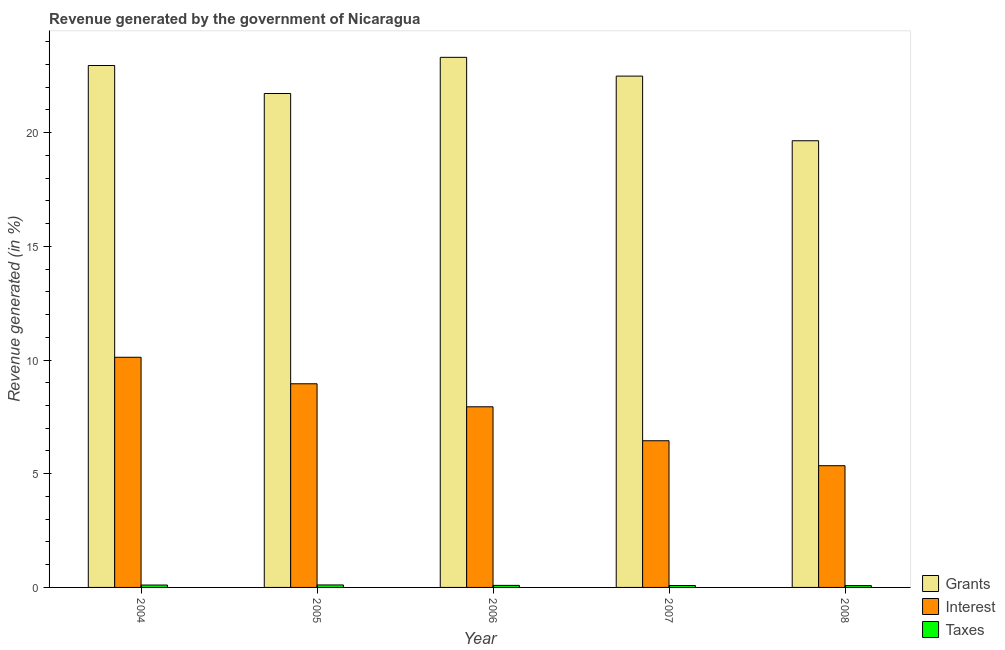How many groups of bars are there?
Your response must be concise. 5. Are the number of bars per tick equal to the number of legend labels?
Make the answer very short. Yes. Are the number of bars on each tick of the X-axis equal?
Offer a terse response. Yes. How many bars are there on the 4th tick from the left?
Make the answer very short. 3. What is the percentage of revenue generated by grants in 2004?
Offer a terse response. 22.95. Across all years, what is the maximum percentage of revenue generated by grants?
Ensure brevity in your answer.  23.31. Across all years, what is the minimum percentage of revenue generated by interest?
Offer a very short reply. 5.35. In which year was the percentage of revenue generated by grants maximum?
Your answer should be compact. 2006. What is the total percentage of revenue generated by interest in the graph?
Ensure brevity in your answer.  38.82. What is the difference between the percentage of revenue generated by grants in 2006 and that in 2007?
Your answer should be very brief. 0.83. What is the difference between the percentage of revenue generated by taxes in 2006 and the percentage of revenue generated by grants in 2008?
Offer a very short reply. 0.01. What is the average percentage of revenue generated by interest per year?
Provide a short and direct response. 7.76. In how many years, is the percentage of revenue generated by interest greater than 18 %?
Your response must be concise. 0. What is the ratio of the percentage of revenue generated by interest in 2006 to that in 2008?
Keep it short and to the point. 1.48. Is the percentage of revenue generated by taxes in 2006 less than that in 2008?
Provide a short and direct response. No. What is the difference between the highest and the second highest percentage of revenue generated by grants?
Offer a terse response. 0.36. What is the difference between the highest and the lowest percentage of revenue generated by interest?
Give a very brief answer. 4.77. What does the 3rd bar from the left in 2004 represents?
Provide a short and direct response. Taxes. What does the 1st bar from the right in 2005 represents?
Provide a succinct answer. Taxes. Is it the case that in every year, the sum of the percentage of revenue generated by grants and percentage of revenue generated by interest is greater than the percentage of revenue generated by taxes?
Give a very brief answer. Yes. How many bars are there?
Your response must be concise. 15. Are all the bars in the graph horizontal?
Your response must be concise. No. What is the difference between two consecutive major ticks on the Y-axis?
Your answer should be very brief. 5. Does the graph contain any zero values?
Offer a very short reply. No. Where does the legend appear in the graph?
Your response must be concise. Bottom right. What is the title of the graph?
Give a very brief answer. Revenue generated by the government of Nicaragua. Does "Unemployment benefits" appear as one of the legend labels in the graph?
Provide a short and direct response. No. What is the label or title of the X-axis?
Offer a terse response. Year. What is the label or title of the Y-axis?
Provide a succinct answer. Revenue generated (in %). What is the Revenue generated (in %) in Grants in 2004?
Your answer should be very brief. 22.95. What is the Revenue generated (in %) in Interest in 2004?
Give a very brief answer. 10.12. What is the Revenue generated (in %) of Taxes in 2004?
Your answer should be compact. 0.1. What is the Revenue generated (in %) of Grants in 2005?
Your answer should be very brief. 21.72. What is the Revenue generated (in %) of Interest in 2005?
Offer a terse response. 8.96. What is the Revenue generated (in %) in Taxes in 2005?
Keep it short and to the point. 0.11. What is the Revenue generated (in %) of Grants in 2006?
Provide a succinct answer. 23.31. What is the Revenue generated (in %) in Interest in 2006?
Give a very brief answer. 7.94. What is the Revenue generated (in %) in Taxes in 2006?
Ensure brevity in your answer.  0.09. What is the Revenue generated (in %) in Grants in 2007?
Your answer should be very brief. 22.48. What is the Revenue generated (in %) of Interest in 2007?
Provide a short and direct response. 6.45. What is the Revenue generated (in %) of Taxes in 2007?
Make the answer very short. 0.08. What is the Revenue generated (in %) in Grants in 2008?
Offer a terse response. 19.64. What is the Revenue generated (in %) in Interest in 2008?
Your answer should be very brief. 5.35. What is the Revenue generated (in %) of Taxes in 2008?
Offer a terse response. 0.08. Across all years, what is the maximum Revenue generated (in %) in Grants?
Your answer should be very brief. 23.31. Across all years, what is the maximum Revenue generated (in %) in Interest?
Your answer should be very brief. 10.12. Across all years, what is the maximum Revenue generated (in %) in Taxes?
Ensure brevity in your answer.  0.11. Across all years, what is the minimum Revenue generated (in %) of Grants?
Provide a succinct answer. 19.64. Across all years, what is the minimum Revenue generated (in %) of Interest?
Offer a very short reply. 5.35. Across all years, what is the minimum Revenue generated (in %) in Taxes?
Offer a very short reply. 0.08. What is the total Revenue generated (in %) in Grants in the graph?
Provide a short and direct response. 110.11. What is the total Revenue generated (in %) of Interest in the graph?
Your answer should be very brief. 38.82. What is the total Revenue generated (in %) of Taxes in the graph?
Your response must be concise. 0.47. What is the difference between the Revenue generated (in %) of Grants in 2004 and that in 2005?
Keep it short and to the point. 1.23. What is the difference between the Revenue generated (in %) in Interest in 2004 and that in 2005?
Offer a terse response. 1.17. What is the difference between the Revenue generated (in %) of Taxes in 2004 and that in 2005?
Keep it short and to the point. -0. What is the difference between the Revenue generated (in %) of Grants in 2004 and that in 2006?
Give a very brief answer. -0.36. What is the difference between the Revenue generated (in %) in Interest in 2004 and that in 2006?
Your response must be concise. 2.18. What is the difference between the Revenue generated (in %) of Taxes in 2004 and that in 2006?
Ensure brevity in your answer.  0.02. What is the difference between the Revenue generated (in %) in Grants in 2004 and that in 2007?
Your response must be concise. 0.47. What is the difference between the Revenue generated (in %) in Interest in 2004 and that in 2007?
Give a very brief answer. 3.67. What is the difference between the Revenue generated (in %) of Taxes in 2004 and that in 2007?
Offer a terse response. 0.02. What is the difference between the Revenue generated (in %) in Grants in 2004 and that in 2008?
Provide a succinct answer. 3.31. What is the difference between the Revenue generated (in %) in Interest in 2004 and that in 2008?
Keep it short and to the point. 4.77. What is the difference between the Revenue generated (in %) in Taxes in 2004 and that in 2008?
Make the answer very short. 0.03. What is the difference between the Revenue generated (in %) of Grants in 2005 and that in 2006?
Provide a short and direct response. -1.59. What is the difference between the Revenue generated (in %) in Interest in 2005 and that in 2006?
Keep it short and to the point. 1.01. What is the difference between the Revenue generated (in %) in Taxes in 2005 and that in 2006?
Give a very brief answer. 0.02. What is the difference between the Revenue generated (in %) in Grants in 2005 and that in 2007?
Your answer should be very brief. -0.76. What is the difference between the Revenue generated (in %) of Interest in 2005 and that in 2007?
Provide a short and direct response. 2.5. What is the difference between the Revenue generated (in %) of Taxes in 2005 and that in 2007?
Keep it short and to the point. 0.02. What is the difference between the Revenue generated (in %) of Grants in 2005 and that in 2008?
Offer a terse response. 2.08. What is the difference between the Revenue generated (in %) of Interest in 2005 and that in 2008?
Make the answer very short. 3.6. What is the difference between the Revenue generated (in %) in Taxes in 2005 and that in 2008?
Your answer should be compact. 0.03. What is the difference between the Revenue generated (in %) in Grants in 2006 and that in 2007?
Provide a succinct answer. 0.83. What is the difference between the Revenue generated (in %) in Interest in 2006 and that in 2007?
Offer a terse response. 1.49. What is the difference between the Revenue generated (in %) in Taxes in 2006 and that in 2007?
Make the answer very short. 0.01. What is the difference between the Revenue generated (in %) of Grants in 2006 and that in 2008?
Ensure brevity in your answer.  3.67. What is the difference between the Revenue generated (in %) in Interest in 2006 and that in 2008?
Your answer should be compact. 2.59. What is the difference between the Revenue generated (in %) in Taxes in 2006 and that in 2008?
Make the answer very short. 0.01. What is the difference between the Revenue generated (in %) in Grants in 2007 and that in 2008?
Offer a very short reply. 2.84. What is the difference between the Revenue generated (in %) in Interest in 2007 and that in 2008?
Your answer should be compact. 1.1. What is the difference between the Revenue generated (in %) in Taxes in 2007 and that in 2008?
Offer a terse response. 0. What is the difference between the Revenue generated (in %) in Grants in 2004 and the Revenue generated (in %) in Interest in 2005?
Provide a short and direct response. 14. What is the difference between the Revenue generated (in %) in Grants in 2004 and the Revenue generated (in %) in Taxes in 2005?
Offer a terse response. 22.84. What is the difference between the Revenue generated (in %) of Interest in 2004 and the Revenue generated (in %) of Taxes in 2005?
Provide a short and direct response. 10.01. What is the difference between the Revenue generated (in %) of Grants in 2004 and the Revenue generated (in %) of Interest in 2006?
Offer a terse response. 15.01. What is the difference between the Revenue generated (in %) in Grants in 2004 and the Revenue generated (in %) in Taxes in 2006?
Your answer should be very brief. 22.86. What is the difference between the Revenue generated (in %) in Interest in 2004 and the Revenue generated (in %) in Taxes in 2006?
Your answer should be compact. 10.03. What is the difference between the Revenue generated (in %) in Grants in 2004 and the Revenue generated (in %) in Interest in 2007?
Offer a very short reply. 16.5. What is the difference between the Revenue generated (in %) in Grants in 2004 and the Revenue generated (in %) in Taxes in 2007?
Ensure brevity in your answer.  22.87. What is the difference between the Revenue generated (in %) of Interest in 2004 and the Revenue generated (in %) of Taxes in 2007?
Your answer should be very brief. 10.04. What is the difference between the Revenue generated (in %) of Grants in 2004 and the Revenue generated (in %) of Interest in 2008?
Offer a terse response. 17.6. What is the difference between the Revenue generated (in %) of Grants in 2004 and the Revenue generated (in %) of Taxes in 2008?
Offer a terse response. 22.87. What is the difference between the Revenue generated (in %) of Interest in 2004 and the Revenue generated (in %) of Taxes in 2008?
Give a very brief answer. 10.04. What is the difference between the Revenue generated (in %) of Grants in 2005 and the Revenue generated (in %) of Interest in 2006?
Offer a terse response. 13.78. What is the difference between the Revenue generated (in %) in Grants in 2005 and the Revenue generated (in %) in Taxes in 2006?
Your answer should be very brief. 21.63. What is the difference between the Revenue generated (in %) in Interest in 2005 and the Revenue generated (in %) in Taxes in 2006?
Make the answer very short. 8.87. What is the difference between the Revenue generated (in %) of Grants in 2005 and the Revenue generated (in %) of Interest in 2007?
Your response must be concise. 15.27. What is the difference between the Revenue generated (in %) in Grants in 2005 and the Revenue generated (in %) in Taxes in 2007?
Keep it short and to the point. 21.64. What is the difference between the Revenue generated (in %) of Interest in 2005 and the Revenue generated (in %) of Taxes in 2007?
Provide a succinct answer. 8.87. What is the difference between the Revenue generated (in %) of Grants in 2005 and the Revenue generated (in %) of Interest in 2008?
Offer a terse response. 16.37. What is the difference between the Revenue generated (in %) of Grants in 2005 and the Revenue generated (in %) of Taxes in 2008?
Keep it short and to the point. 21.64. What is the difference between the Revenue generated (in %) of Interest in 2005 and the Revenue generated (in %) of Taxes in 2008?
Your answer should be very brief. 8.88. What is the difference between the Revenue generated (in %) of Grants in 2006 and the Revenue generated (in %) of Interest in 2007?
Provide a succinct answer. 16.86. What is the difference between the Revenue generated (in %) of Grants in 2006 and the Revenue generated (in %) of Taxes in 2007?
Provide a short and direct response. 23.23. What is the difference between the Revenue generated (in %) of Interest in 2006 and the Revenue generated (in %) of Taxes in 2007?
Ensure brevity in your answer.  7.86. What is the difference between the Revenue generated (in %) in Grants in 2006 and the Revenue generated (in %) in Interest in 2008?
Offer a terse response. 17.96. What is the difference between the Revenue generated (in %) in Grants in 2006 and the Revenue generated (in %) in Taxes in 2008?
Your answer should be very brief. 23.23. What is the difference between the Revenue generated (in %) in Interest in 2006 and the Revenue generated (in %) in Taxes in 2008?
Provide a short and direct response. 7.86. What is the difference between the Revenue generated (in %) of Grants in 2007 and the Revenue generated (in %) of Interest in 2008?
Offer a terse response. 17.13. What is the difference between the Revenue generated (in %) in Grants in 2007 and the Revenue generated (in %) in Taxes in 2008?
Your answer should be compact. 22.41. What is the difference between the Revenue generated (in %) of Interest in 2007 and the Revenue generated (in %) of Taxes in 2008?
Ensure brevity in your answer.  6.37. What is the average Revenue generated (in %) in Grants per year?
Ensure brevity in your answer.  22.02. What is the average Revenue generated (in %) in Interest per year?
Your answer should be very brief. 7.76. What is the average Revenue generated (in %) in Taxes per year?
Keep it short and to the point. 0.09. In the year 2004, what is the difference between the Revenue generated (in %) of Grants and Revenue generated (in %) of Interest?
Ensure brevity in your answer.  12.83. In the year 2004, what is the difference between the Revenue generated (in %) in Grants and Revenue generated (in %) in Taxes?
Make the answer very short. 22.85. In the year 2004, what is the difference between the Revenue generated (in %) in Interest and Revenue generated (in %) in Taxes?
Keep it short and to the point. 10.02. In the year 2005, what is the difference between the Revenue generated (in %) in Grants and Revenue generated (in %) in Interest?
Ensure brevity in your answer.  12.76. In the year 2005, what is the difference between the Revenue generated (in %) in Grants and Revenue generated (in %) in Taxes?
Your answer should be compact. 21.61. In the year 2005, what is the difference between the Revenue generated (in %) in Interest and Revenue generated (in %) in Taxes?
Your response must be concise. 8.85. In the year 2006, what is the difference between the Revenue generated (in %) in Grants and Revenue generated (in %) in Interest?
Provide a succinct answer. 15.37. In the year 2006, what is the difference between the Revenue generated (in %) of Grants and Revenue generated (in %) of Taxes?
Make the answer very short. 23.22. In the year 2006, what is the difference between the Revenue generated (in %) in Interest and Revenue generated (in %) in Taxes?
Provide a short and direct response. 7.85. In the year 2007, what is the difference between the Revenue generated (in %) in Grants and Revenue generated (in %) in Interest?
Your answer should be very brief. 16.03. In the year 2007, what is the difference between the Revenue generated (in %) of Grants and Revenue generated (in %) of Taxes?
Offer a very short reply. 22.4. In the year 2007, what is the difference between the Revenue generated (in %) of Interest and Revenue generated (in %) of Taxes?
Your answer should be very brief. 6.37. In the year 2008, what is the difference between the Revenue generated (in %) in Grants and Revenue generated (in %) in Interest?
Give a very brief answer. 14.29. In the year 2008, what is the difference between the Revenue generated (in %) of Grants and Revenue generated (in %) of Taxes?
Keep it short and to the point. 19.56. In the year 2008, what is the difference between the Revenue generated (in %) in Interest and Revenue generated (in %) in Taxes?
Ensure brevity in your answer.  5.27. What is the ratio of the Revenue generated (in %) in Grants in 2004 to that in 2005?
Your response must be concise. 1.06. What is the ratio of the Revenue generated (in %) in Interest in 2004 to that in 2005?
Provide a short and direct response. 1.13. What is the ratio of the Revenue generated (in %) of Taxes in 2004 to that in 2005?
Your response must be concise. 0.96. What is the ratio of the Revenue generated (in %) of Grants in 2004 to that in 2006?
Give a very brief answer. 0.98. What is the ratio of the Revenue generated (in %) in Interest in 2004 to that in 2006?
Offer a terse response. 1.27. What is the ratio of the Revenue generated (in %) of Taxes in 2004 to that in 2006?
Provide a succinct answer. 1.17. What is the ratio of the Revenue generated (in %) in Grants in 2004 to that in 2007?
Your response must be concise. 1.02. What is the ratio of the Revenue generated (in %) of Interest in 2004 to that in 2007?
Your answer should be very brief. 1.57. What is the ratio of the Revenue generated (in %) in Taxes in 2004 to that in 2007?
Offer a terse response. 1.24. What is the ratio of the Revenue generated (in %) in Grants in 2004 to that in 2008?
Your response must be concise. 1.17. What is the ratio of the Revenue generated (in %) in Interest in 2004 to that in 2008?
Provide a succinct answer. 1.89. What is the ratio of the Revenue generated (in %) of Taxes in 2004 to that in 2008?
Keep it short and to the point. 1.31. What is the ratio of the Revenue generated (in %) of Grants in 2005 to that in 2006?
Keep it short and to the point. 0.93. What is the ratio of the Revenue generated (in %) in Interest in 2005 to that in 2006?
Provide a short and direct response. 1.13. What is the ratio of the Revenue generated (in %) of Taxes in 2005 to that in 2006?
Make the answer very short. 1.22. What is the ratio of the Revenue generated (in %) of Grants in 2005 to that in 2007?
Offer a terse response. 0.97. What is the ratio of the Revenue generated (in %) of Interest in 2005 to that in 2007?
Provide a short and direct response. 1.39. What is the ratio of the Revenue generated (in %) of Taxes in 2005 to that in 2007?
Make the answer very short. 1.29. What is the ratio of the Revenue generated (in %) in Grants in 2005 to that in 2008?
Provide a short and direct response. 1.11. What is the ratio of the Revenue generated (in %) in Interest in 2005 to that in 2008?
Give a very brief answer. 1.67. What is the ratio of the Revenue generated (in %) in Taxes in 2005 to that in 2008?
Provide a short and direct response. 1.37. What is the ratio of the Revenue generated (in %) in Grants in 2006 to that in 2007?
Offer a very short reply. 1.04. What is the ratio of the Revenue generated (in %) in Interest in 2006 to that in 2007?
Provide a short and direct response. 1.23. What is the ratio of the Revenue generated (in %) in Taxes in 2006 to that in 2007?
Provide a succinct answer. 1.06. What is the ratio of the Revenue generated (in %) in Grants in 2006 to that in 2008?
Your answer should be very brief. 1.19. What is the ratio of the Revenue generated (in %) of Interest in 2006 to that in 2008?
Offer a terse response. 1.48. What is the ratio of the Revenue generated (in %) in Taxes in 2006 to that in 2008?
Offer a very short reply. 1.12. What is the ratio of the Revenue generated (in %) of Grants in 2007 to that in 2008?
Give a very brief answer. 1.14. What is the ratio of the Revenue generated (in %) of Interest in 2007 to that in 2008?
Your answer should be very brief. 1.21. What is the ratio of the Revenue generated (in %) of Taxes in 2007 to that in 2008?
Ensure brevity in your answer.  1.06. What is the difference between the highest and the second highest Revenue generated (in %) of Grants?
Offer a terse response. 0.36. What is the difference between the highest and the second highest Revenue generated (in %) in Interest?
Your answer should be very brief. 1.17. What is the difference between the highest and the second highest Revenue generated (in %) of Taxes?
Offer a terse response. 0. What is the difference between the highest and the lowest Revenue generated (in %) in Grants?
Your response must be concise. 3.67. What is the difference between the highest and the lowest Revenue generated (in %) in Interest?
Your answer should be compact. 4.77. What is the difference between the highest and the lowest Revenue generated (in %) in Taxes?
Offer a very short reply. 0.03. 